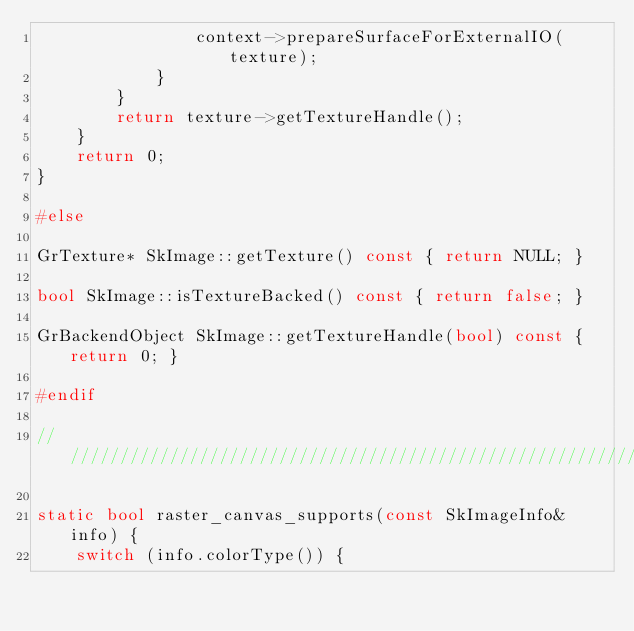Convert code to text. <code><loc_0><loc_0><loc_500><loc_500><_C++_>                context->prepareSurfaceForExternalIO(texture);
            }
        }
        return texture->getTextureHandle();
    }
    return 0;
}

#else

GrTexture* SkImage::getTexture() const { return NULL; }

bool SkImage::isTextureBacked() const { return false; }

GrBackendObject SkImage::getTextureHandle(bool) const { return 0; }

#endif

///////////////////////////////////////////////////////////////////////////////

static bool raster_canvas_supports(const SkImageInfo& info) {
    switch (info.colorType()) {</code> 